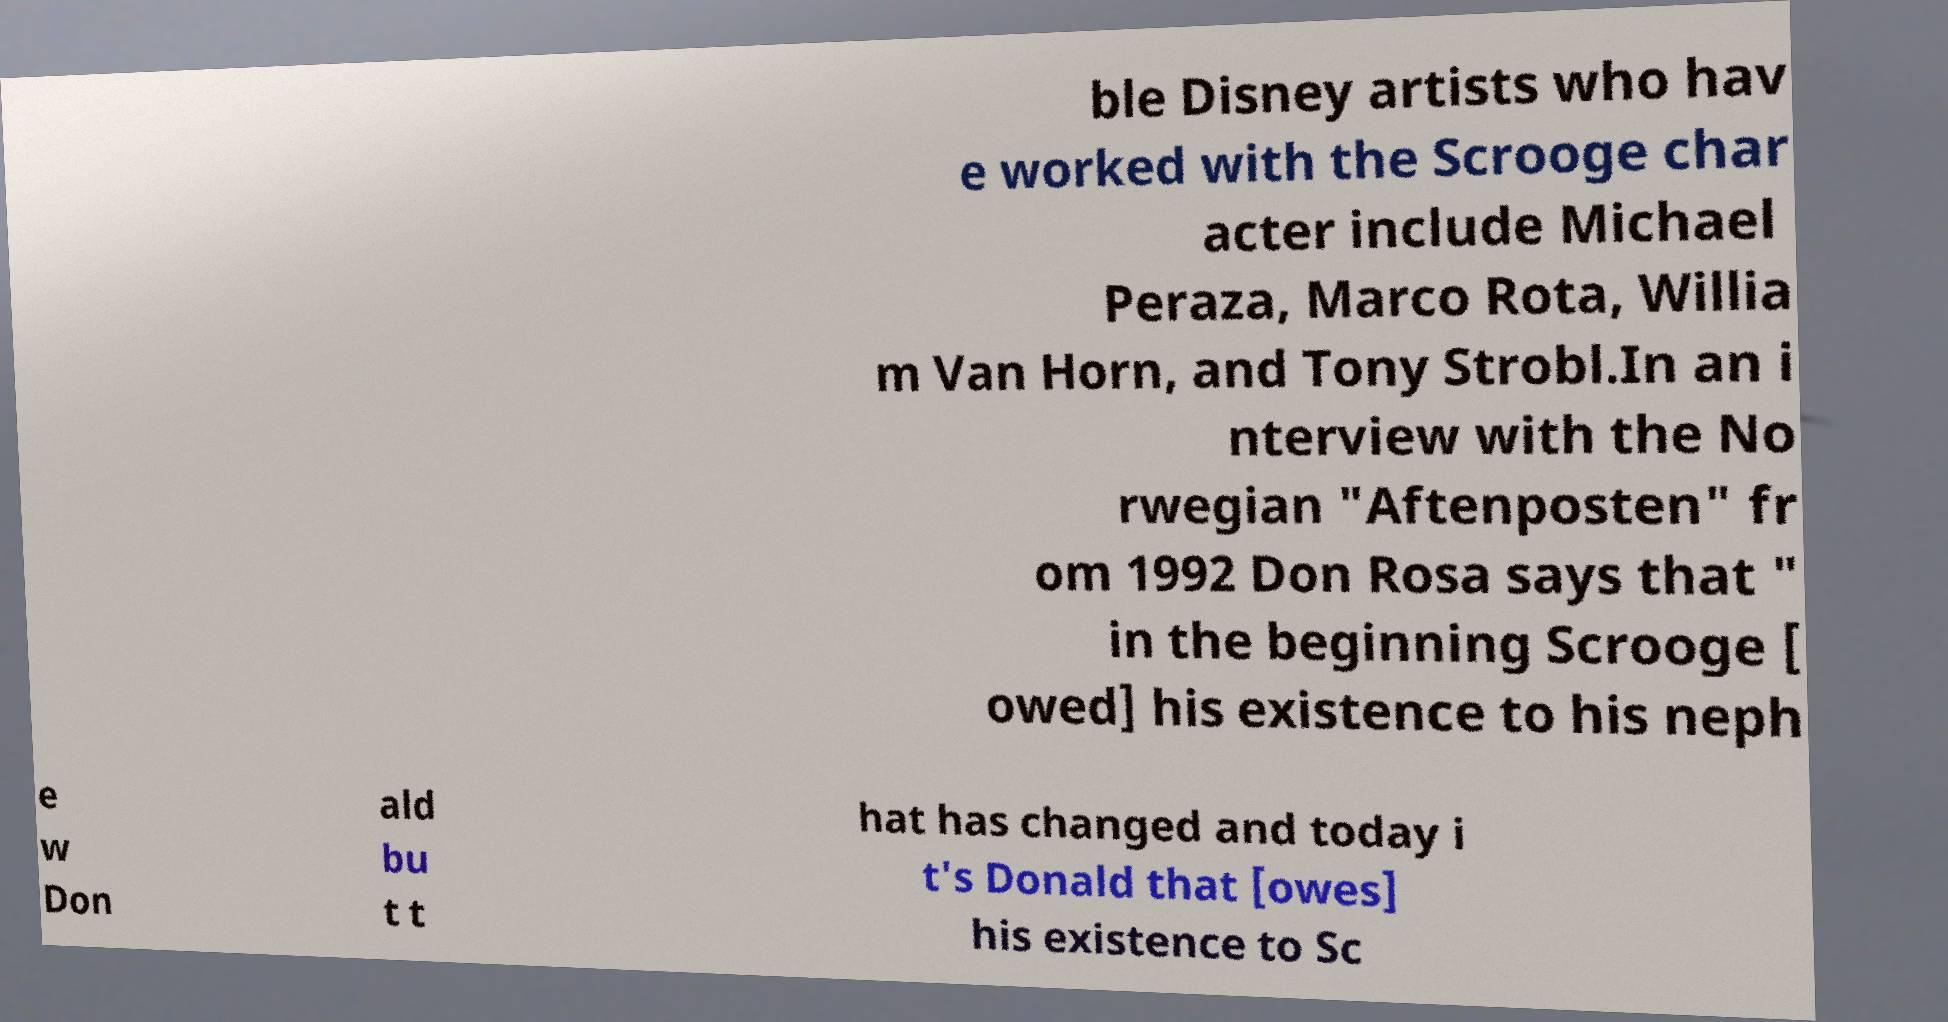Please read and relay the text visible in this image. What does it say? ble Disney artists who hav e worked with the Scrooge char acter include Michael Peraza, Marco Rota, Willia m Van Horn, and Tony Strobl.In an i nterview with the No rwegian "Aftenposten" fr om 1992 Don Rosa says that " in the beginning Scrooge [ owed] his existence to his neph e w Don ald bu t t hat has changed and today i t's Donald that [owes] his existence to Sc 